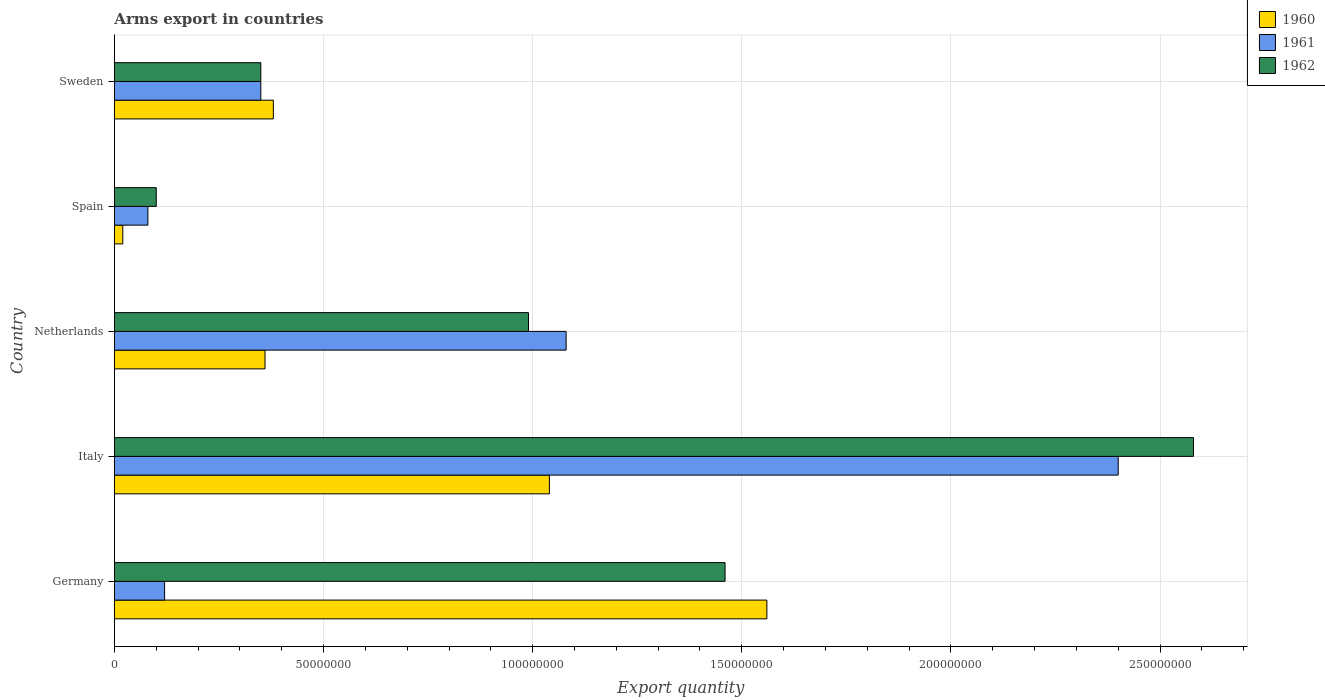How many different coloured bars are there?
Make the answer very short. 3. How many groups of bars are there?
Your response must be concise. 5. Are the number of bars on each tick of the Y-axis equal?
Make the answer very short. Yes. What is the label of the 5th group of bars from the top?
Provide a succinct answer. Germany. What is the total arms export in 1962 in Germany?
Provide a succinct answer. 1.46e+08. Across all countries, what is the maximum total arms export in 1961?
Your response must be concise. 2.40e+08. In which country was the total arms export in 1960 minimum?
Keep it short and to the point. Spain. What is the total total arms export in 1961 in the graph?
Make the answer very short. 4.03e+08. What is the difference between the total arms export in 1960 in Italy and that in Spain?
Offer a terse response. 1.02e+08. What is the difference between the total arms export in 1961 in Netherlands and the total arms export in 1960 in Sweden?
Your answer should be compact. 7.00e+07. What is the average total arms export in 1960 per country?
Give a very brief answer. 6.72e+07. What is the difference between the total arms export in 1962 and total arms export in 1961 in Spain?
Provide a succinct answer. 2.00e+06. In how many countries, is the total arms export in 1962 greater than 190000000 ?
Provide a succinct answer. 1. What is the ratio of the total arms export in 1961 in Germany to that in Italy?
Offer a terse response. 0.05. Is the total arms export in 1960 in Italy less than that in Sweden?
Provide a succinct answer. No. Is the difference between the total arms export in 1962 in Germany and Spain greater than the difference between the total arms export in 1961 in Germany and Spain?
Provide a short and direct response. Yes. What is the difference between the highest and the second highest total arms export in 1960?
Your answer should be very brief. 5.20e+07. What is the difference between the highest and the lowest total arms export in 1961?
Your response must be concise. 2.32e+08. In how many countries, is the total arms export in 1962 greater than the average total arms export in 1962 taken over all countries?
Keep it short and to the point. 2. What does the 1st bar from the bottom in Netherlands represents?
Keep it short and to the point. 1960. Is it the case that in every country, the sum of the total arms export in 1962 and total arms export in 1960 is greater than the total arms export in 1961?
Provide a short and direct response. Yes. How many bars are there?
Your answer should be compact. 15. Where does the legend appear in the graph?
Make the answer very short. Top right. How many legend labels are there?
Ensure brevity in your answer.  3. What is the title of the graph?
Make the answer very short. Arms export in countries. Does "1967" appear as one of the legend labels in the graph?
Your response must be concise. No. What is the label or title of the X-axis?
Provide a short and direct response. Export quantity. What is the Export quantity in 1960 in Germany?
Your response must be concise. 1.56e+08. What is the Export quantity of 1962 in Germany?
Your answer should be compact. 1.46e+08. What is the Export quantity of 1960 in Italy?
Your response must be concise. 1.04e+08. What is the Export quantity in 1961 in Italy?
Your answer should be compact. 2.40e+08. What is the Export quantity in 1962 in Italy?
Your answer should be very brief. 2.58e+08. What is the Export quantity in 1960 in Netherlands?
Provide a short and direct response. 3.60e+07. What is the Export quantity in 1961 in Netherlands?
Offer a very short reply. 1.08e+08. What is the Export quantity in 1962 in Netherlands?
Offer a very short reply. 9.90e+07. What is the Export quantity of 1960 in Spain?
Ensure brevity in your answer.  2.00e+06. What is the Export quantity in 1960 in Sweden?
Offer a terse response. 3.80e+07. What is the Export quantity of 1961 in Sweden?
Ensure brevity in your answer.  3.50e+07. What is the Export quantity in 1962 in Sweden?
Give a very brief answer. 3.50e+07. Across all countries, what is the maximum Export quantity in 1960?
Your response must be concise. 1.56e+08. Across all countries, what is the maximum Export quantity of 1961?
Ensure brevity in your answer.  2.40e+08. Across all countries, what is the maximum Export quantity of 1962?
Keep it short and to the point. 2.58e+08. Across all countries, what is the minimum Export quantity of 1961?
Your answer should be very brief. 8.00e+06. What is the total Export quantity of 1960 in the graph?
Your answer should be compact. 3.36e+08. What is the total Export quantity in 1961 in the graph?
Give a very brief answer. 4.03e+08. What is the total Export quantity of 1962 in the graph?
Make the answer very short. 5.48e+08. What is the difference between the Export quantity of 1960 in Germany and that in Italy?
Give a very brief answer. 5.20e+07. What is the difference between the Export quantity in 1961 in Germany and that in Italy?
Provide a short and direct response. -2.28e+08. What is the difference between the Export quantity in 1962 in Germany and that in Italy?
Keep it short and to the point. -1.12e+08. What is the difference between the Export quantity in 1960 in Germany and that in Netherlands?
Ensure brevity in your answer.  1.20e+08. What is the difference between the Export quantity in 1961 in Germany and that in Netherlands?
Offer a terse response. -9.60e+07. What is the difference between the Export quantity in 1962 in Germany and that in Netherlands?
Provide a succinct answer. 4.70e+07. What is the difference between the Export quantity of 1960 in Germany and that in Spain?
Offer a very short reply. 1.54e+08. What is the difference between the Export quantity of 1962 in Germany and that in Spain?
Provide a short and direct response. 1.36e+08. What is the difference between the Export quantity of 1960 in Germany and that in Sweden?
Your answer should be compact. 1.18e+08. What is the difference between the Export quantity of 1961 in Germany and that in Sweden?
Make the answer very short. -2.30e+07. What is the difference between the Export quantity in 1962 in Germany and that in Sweden?
Make the answer very short. 1.11e+08. What is the difference between the Export quantity of 1960 in Italy and that in Netherlands?
Ensure brevity in your answer.  6.80e+07. What is the difference between the Export quantity of 1961 in Italy and that in Netherlands?
Your answer should be compact. 1.32e+08. What is the difference between the Export quantity in 1962 in Italy and that in Netherlands?
Keep it short and to the point. 1.59e+08. What is the difference between the Export quantity in 1960 in Italy and that in Spain?
Offer a terse response. 1.02e+08. What is the difference between the Export quantity of 1961 in Italy and that in Spain?
Your answer should be compact. 2.32e+08. What is the difference between the Export quantity of 1962 in Italy and that in Spain?
Your answer should be very brief. 2.48e+08. What is the difference between the Export quantity of 1960 in Italy and that in Sweden?
Keep it short and to the point. 6.60e+07. What is the difference between the Export quantity of 1961 in Italy and that in Sweden?
Make the answer very short. 2.05e+08. What is the difference between the Export quantity of 1962 in Italy and that in Sweden?
Your answer should be compact. 2.23e+08. What is the difference between the Export quantity of 1960 in Netherlands and that in Spain?
Your answer should be very brief. 3.40e+07. What is the difference between the Export quantity in 1962 in Netherlands and that in Spain?
Make the answer very short. 8.90e+07. What is the difference between the Export quantity of 1960 in Netherlands and that in Sweden?
Your answer should be compact. -2.00e+06. What is the difference between the Export quantity of 1961 in Netherlands and that in Sweden?
Make the answer very short. 7.30e+07. What is the difference between the Export quantity in 1962 in Netherlands and that in Sweden?
Give a very brief answer. 6.40e+07. What is the difference between the Export quantity in 1960 in Spain and that in Sweden?
Keep it short and to the point. -3.60e+07. What is the difference between the Export quantity of 1961 in Spain and that in Sweden?
Offer a very short reply. -2.70e+07. What is the difference between the Export quantity of 1962 in Spain and that in Sweden?
Your response must be concise. -2.50e+07. What is the difference between the Export quantity in 1960 in Germany and the Export quantity in 1961 in Italy?
Provide a short and direct response. -8.40e+07. What is the difference between the Export quantity of 1960 in Germany and the Export quantity of 1962 in Italy?
Provide a short and direct response. -1.02e+08. What is the difference between the Export quantity in 1961 in Germany and the Export quantity in 1962 in Italy?
Your response must be concise. -2.46e+08. What is the difference between the Export quantity in 1960 in Germany and the Export quantity in 1961 in Netherlands?
Offer a terse response. 4.80e+07. What is the difference between the Export quantity in 1960 in Germany and the Export quantity in 1962 in Netherlands?
Offer a terse response. 5.70e+07. What is the difference between the Export quantity of 1961 in Germany and the Export quantity of 1962 in Netherlands?
Give a very brief answer. -8.70e+07. What is the difference between the Export quantity of 1960 in Germany and the Export quantity of 1961 in Spain?
Keep it short and to the point. 1.48e+08. What is the difference between the Export quantity in 1960 in Germany and the Export quantity in 1962 in Spain?
Provide a short and direct response. 1.46e+08. What is the difference between the Export quantity in 1960 in Germany and the Export quantity in 1961 in Sweden?
Provide a short and direct response. 1.21e+08. What is the difference between the Export quantity of 1960 in Germany and the Export quantity of 1962 in Sweden?
Your answer should be compact. 1.21e+08. What is the difference between the Export quantity in 1961 in Germany and the Export quantity in 1962 in Sweden?
Provide a short and direct response. -2.30e+07. What is the difference between the Export quantity in 1961 in Italy and the Export quantity in 1962 in Netherlands?
Ensure brevity in your answer.  1.41e+08. What is the difference between the Export quantity in 1960 in Italy and the Export quantity in 1961 in Spain?
Make the answer very short. 9.60e+07. What is the difference between the Export quantity of 1960 in Italy and the Export quantity of 1962 in Spain?
Offer a very short reply. 9.40e+07. What is the difference between the Export quantity of 1961 in Italy and the Export quantity of 1962 in Spain?
Make the answer very short. 2.30e+08. What is the difference between the Export quantity of 1960 in Italy and the Export quantity of 1961 in Sweden?
Offer a terse response. 6.90e+07. What is the difference between the Export quantity in 1960 in Italy and the Export quantity in 1962 in Sweden?
Provide a short and direct response. 6.90e+07. What is the difference between the Export quantity in 1961 in Italy and the Export quantity in 1962 in Sweden?
Make the answer very short. 2.05e+08. What is the difference between the Export quantity in 1960 in Netherlands and the Export quantity in 1961 in Spain?
Offer a very short reply. 2.80e+07. What is the difference between the Export quantity of 1960 in Netherlands and the Export quantity of 1962 in Spain?
Offer a terse response. 2.60e+07. What is the difference between the Export quantity of 1961 in Netherlands and the Export quantity of 1962 in Spain?
Your response must be concise. 9.80e+07. What is the difference between the Export quantity in 1960 in Netherlands and the Export quantity in 1962 in Sweden?
Your answer should be compact. 1.00e+06. What is the difference between the Export quantity of 1961 in Netherlands and the Export quantity of 1962 in Sweden?
Provide a succinct answer. 7.30e+07. What is the difference between the Export quantity of 1960 in Spain and the Export quantity of 1961 in Sweden?
Provide a succinct answer. -3.30e+07. What is the difference between the Export quantity of 1960 in Spain and the Export quantity of 1962 in Sweden?
Offer a terse response. -3.30e+07. What is the difference between the Export quantity of 1961 in Spain and the Export quantity of 1962 in Sweden?
Offer a very short reply. -2.70e+07. What is the average Export quantity of 1960 per country?
Offer a terse response. 6.72e+07. What is the average Export quantity in 1961 per country?
Your response must be concise. 8.06e+07. What is the average Export quantity of 1962 per country?
Your answer should be very brief. 1.10e+08. What is the difference between the Export quantity in 1960 and Export quantity in 1961 in Germany?
Offer a terse response. 1.44e+08. What is the difference between the Export quantity of 1960 and Export quantity of 1962 in Germany?
Provide a succinct answer. 1.00e+07. What is the difference between the Export quantity of 1961 and Export quantity of 1962 in Germany?
Your answer should be compact. -1.34e+08. What is the difference between the Export quantity in 1960 and Export quantity in 1961 in Italy?
Offer a very short reply. -1.36e+08. What is the difference between the Export quantity of 1960 and Export quantity of 1962 in Italy?
Make the answer very short. -1.54e+08. What is the difference between the Export quantity in 1961 and Export quantity in 1962 in Italy?
Ensure brevity in your answer.  -1.80e+07. What is the difference between the Export quantity of 1960 and Export quantity of 1961 in Netherlands?
Keep it short and to the point. -7.20e+07. What is the difference between the Export quantity of 1960 and Export quantity of 1962 in Netherlands?
Your answer should be compact. -6.30e+07. What is the difference between the Export quantity in 1961 and Export quantity in 1962 in Netherlands?
Your answer should be compact. 9.00e+06. What is the difference between the Export quantity in 1960 and Export quantity in 1961 in Spain?
Keep it short and to the point. -6.00e+06. What is the difference between the Export quantity of 1960 and Export quantity of 1962 in Spain?
Your answer should be compact. -8.00e+06. What is the difference between the Export quantity of 1961 and Export quantity of 1962 in Sweden?
Your answer should be compact. 0. What is the ratio of the Export quantity of 1962 in Germany to that in Italy?
Make the answer very short. 0.57. What is the ratio of the Export quantity of 1960 in Germany to that in Netherlands?
Provide a succinct answer. 4.33. What is the ratio of the Export quantity in 1962 in Germany to that in Netherlands?
Your answer should be compact. 1.47. What is the ratio of the Export quantity in 1961 in Germany to that in Spain?
Offer a terse response. 1.5. What is the ratio of the Export quantity of 1962 in Germany to that in Spain?
Ensure brevity in your answer.  14.6. What is the ratio of the Export quantity of 1960 in Germany to that in Sweden?
Give a very brief answer. 4.11. What is the ratio of the Export quantity in 1961 in Germany to that in Sweden?
Offer a very short reply. 0.34. What is the ratio of the Export quantity in 1962 in Germany to that in Sweden?
Provide a succinct answer. 4.17. What is the ratio of the Export quantity in 1960 in Italy to that in Netherlands?
Provide a short and direct response. 2.89. What is the ratio of the Export quantity in 1961 in Italy to that in Netherlands?
Keep it short and to the point. 2.22. What is the ratio of the Export quantity in 1962 in Italy to that in Netherlands?
Provide a succinct answer. 2.61. What is the ratio of the Export quantity of 1961 in Italy to that in Spain?
Offer a terse response. 30. What is the ratio of the Export quantity in 1962 in Italy to that in Spain?
Provide a succinct answer. 25.8. What is the ratio of the Export quantity of 1960 in Italy to that in Sweden?
Provide a short and direct response. 2.74. What is the ratio of the Export quantity in 1961 in Italy to that in Sweden?
Ensure brevity in your answer.  6.86. What is the ratio of the Export quantity in 1962 in Italy to that in Sweden?
Your answer should be compact. 7.37. What is the ratio of the Export quantity in 1960 in Netherlands to that in Spain?
Keep it short and to the point. 18. What is the ratio of the Export quantity of 1962 in Netherlands to that in Spain?
Offer a terse response. 9.9. What is the ratio of the Export quantity of 1960 in Netherlands to that in Sweden?
Offer a very short reply. 0.95. What is the ratio of the Export quantity in 1961 in Netherlands to that in Sweden?
Offer a very short reply. 3.09. What is the ratio of the Export quantity in 1962 in Netherlands to that in Sweden?
Give a very brief answer. 2.83. What is the ratio of the Export quantity of 1960 in Spain to that in Sweden?
Your response must be concise. 0.05. What is the ratio of the Export quantity of 1961 in Spain to that in Sweden?
Provide a short and direct response. 0.23. What is the ratio of the Export quantity of 1962 in Spain to that in Sweden?
Your response must be concise. 0.29. What is the difference between the highest and the second highest Export quantity of 1960?
Keep it short and to the point. 5.20e+07. What is the difference between the highest and the second highest Export quantity in 1961?
Provide a succinct answer. 1.32e+08. What is the difference between the highest and the second highest Export quantity in 1962?
Your answer should be very brief. 1.12e+08. What is the difference between the highest and the lowest Export quantity of 1960?
Provide a short and direct response. 1.54e+08. What is the difference between the highest and the lowest Export quantity of 1961?
Ensure brevity in your answer.  2.32e+08. What is the difference between the highest and the lowest Export quantity in 1962?
Give a very brief answer. 2.48e+08. 